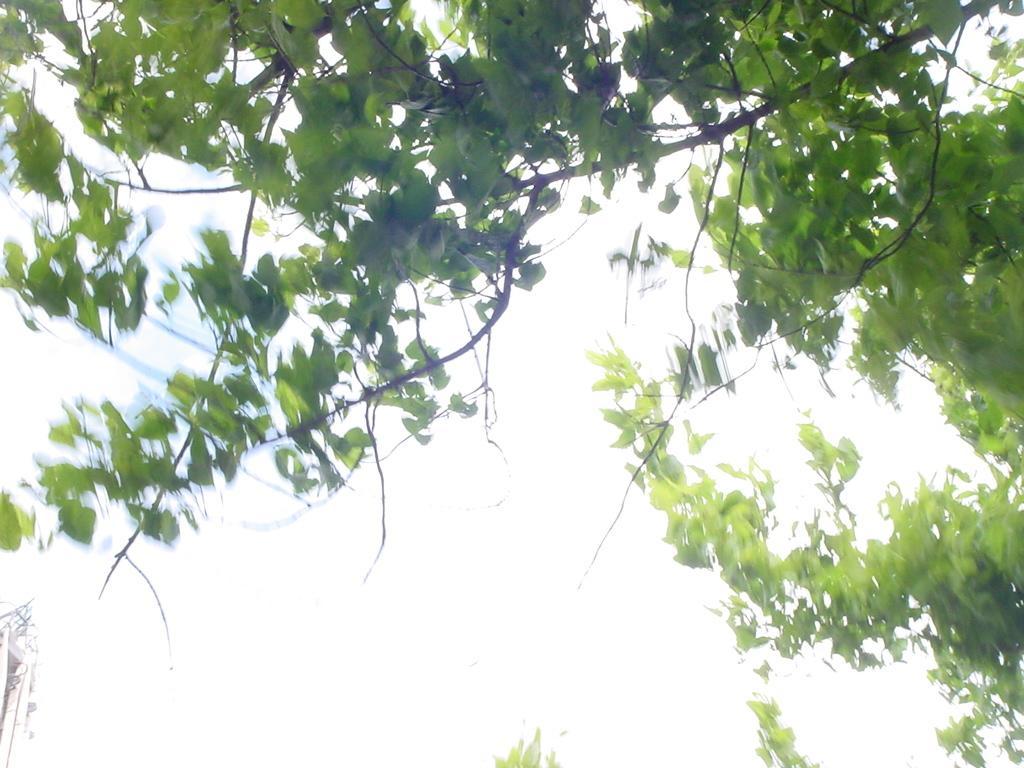Please provide a concise description of this image. We can see green leaves and stems. In the background it is white. 